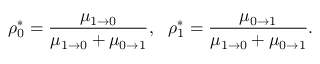Convert formula to latex. <formula><loc_0><loc_0><loc_500><loc_500>\rho _ { 0 } ^ { * } = \frac { \mu _ { 1 \to 0 } } { \mu _ { 1 \to 0 } + \mu _ { 0 \to 1 } } , \rho _ { 1 } ^ { * } = \frac { \mu _ { 0 \to 1 } } { \mu _ { 1 \to 0 } + \mu _ { 0 \to 1 } } .</formula> 